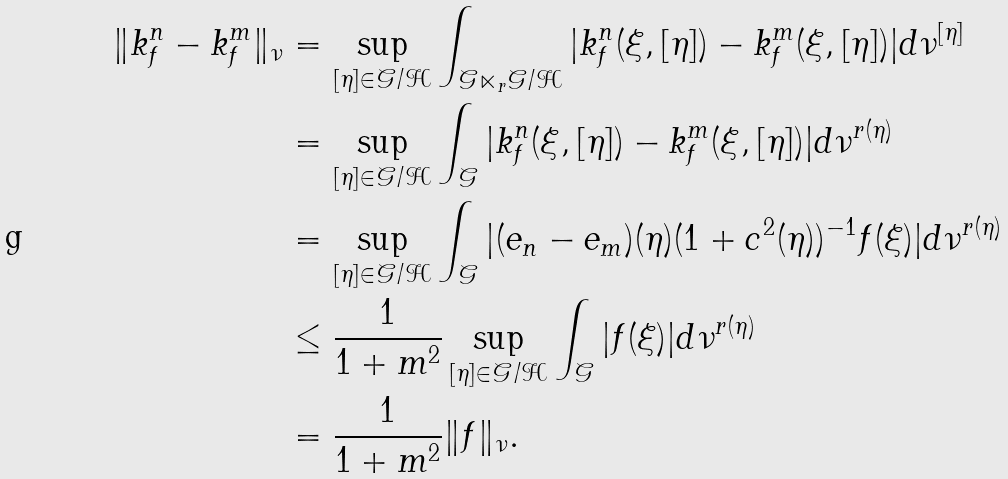<formula> <loc_0><loc_0><loc_500><loc_500>\| k ^ { n } _ { f } - k ^ { m } _ { f } \| _ { \nu } & = \sup _ { [ \eta ] \in \mathcal { G } / \mathcal { H } } \int _ { \mathcal { G } \ltimes _ { r } \mathcal { G } / \mathcal { H } } | k ^ { n } _ { f } ( \xi , [ \eta ] ) - k ^ { m } _ { f } ( \xi , [ \eta ] ) | d \nu ^ { [ \eta ] } \\ & = \sup _ { [ \eta ] \in \mathcal { G } / \mathcal { H } } \int _ { \mathcal { G } } | k _ { f } ^ { n } ( \xi , [ \eta ] ) - k ^ { m } _ { f } ( \xi , [ \eta ] ) | d \nu ^ { r ( \eta ) } \\ & = \sup _ { [ \eta ] \in \mathcal { G } / \mathcal { H } } \int _ { \mathcal { G } } | ( e _ { n } - e _ { m } ) ( \eta ) ( 1 + c ^ { 2 } ( \eta ) ) ^ { - 1 } f ( \xi ) | d \nu ^ { r ( \eta ) } \\ & \leq \frac { 1 } { 1 + m ^ { 2 } } \sup _ { [ \eta ] \in \mathcal { G } / \mathcal { H } } \int _ { \mathcal { G } } | f ( \xi ) | d \nu ^ { r ( \eta ) } \\ & = \frac { 1 } { 1 + m ^ { 2 } } \| f \| _ { \nu } .</formula> 